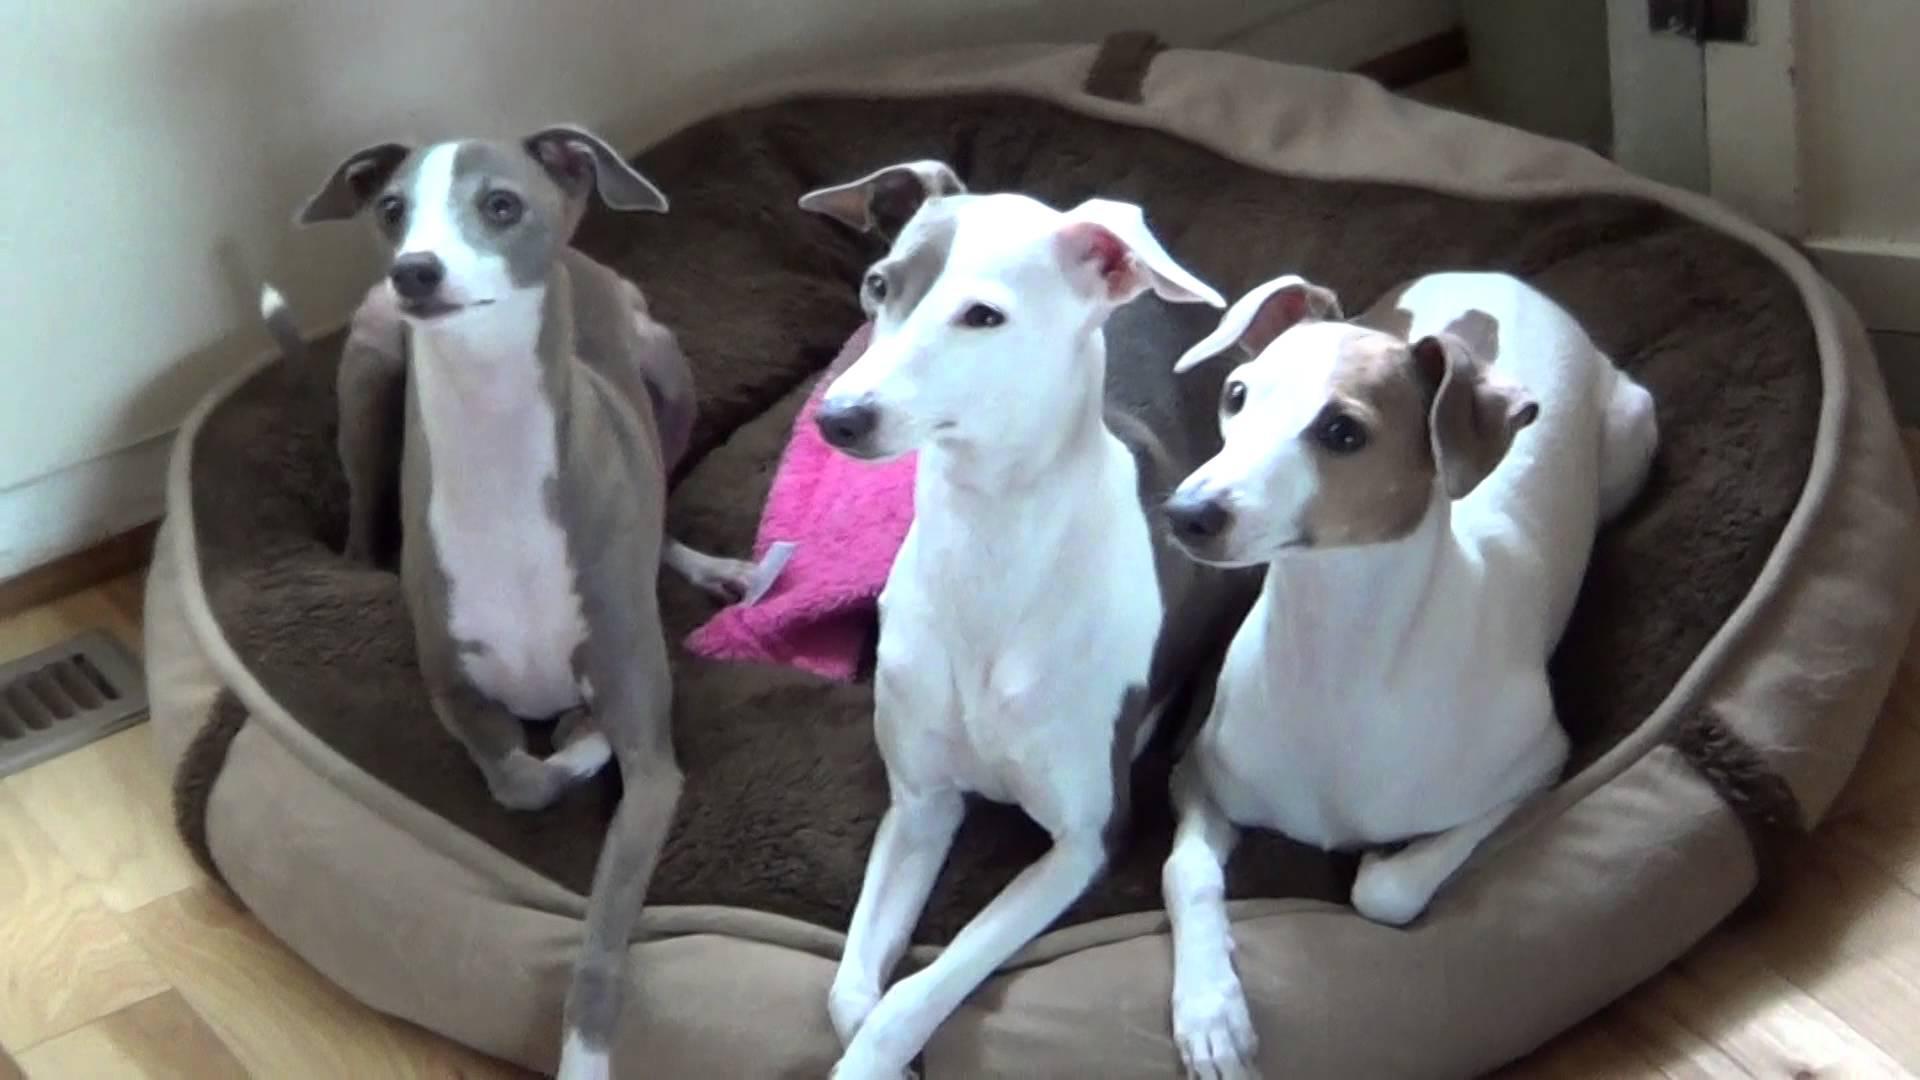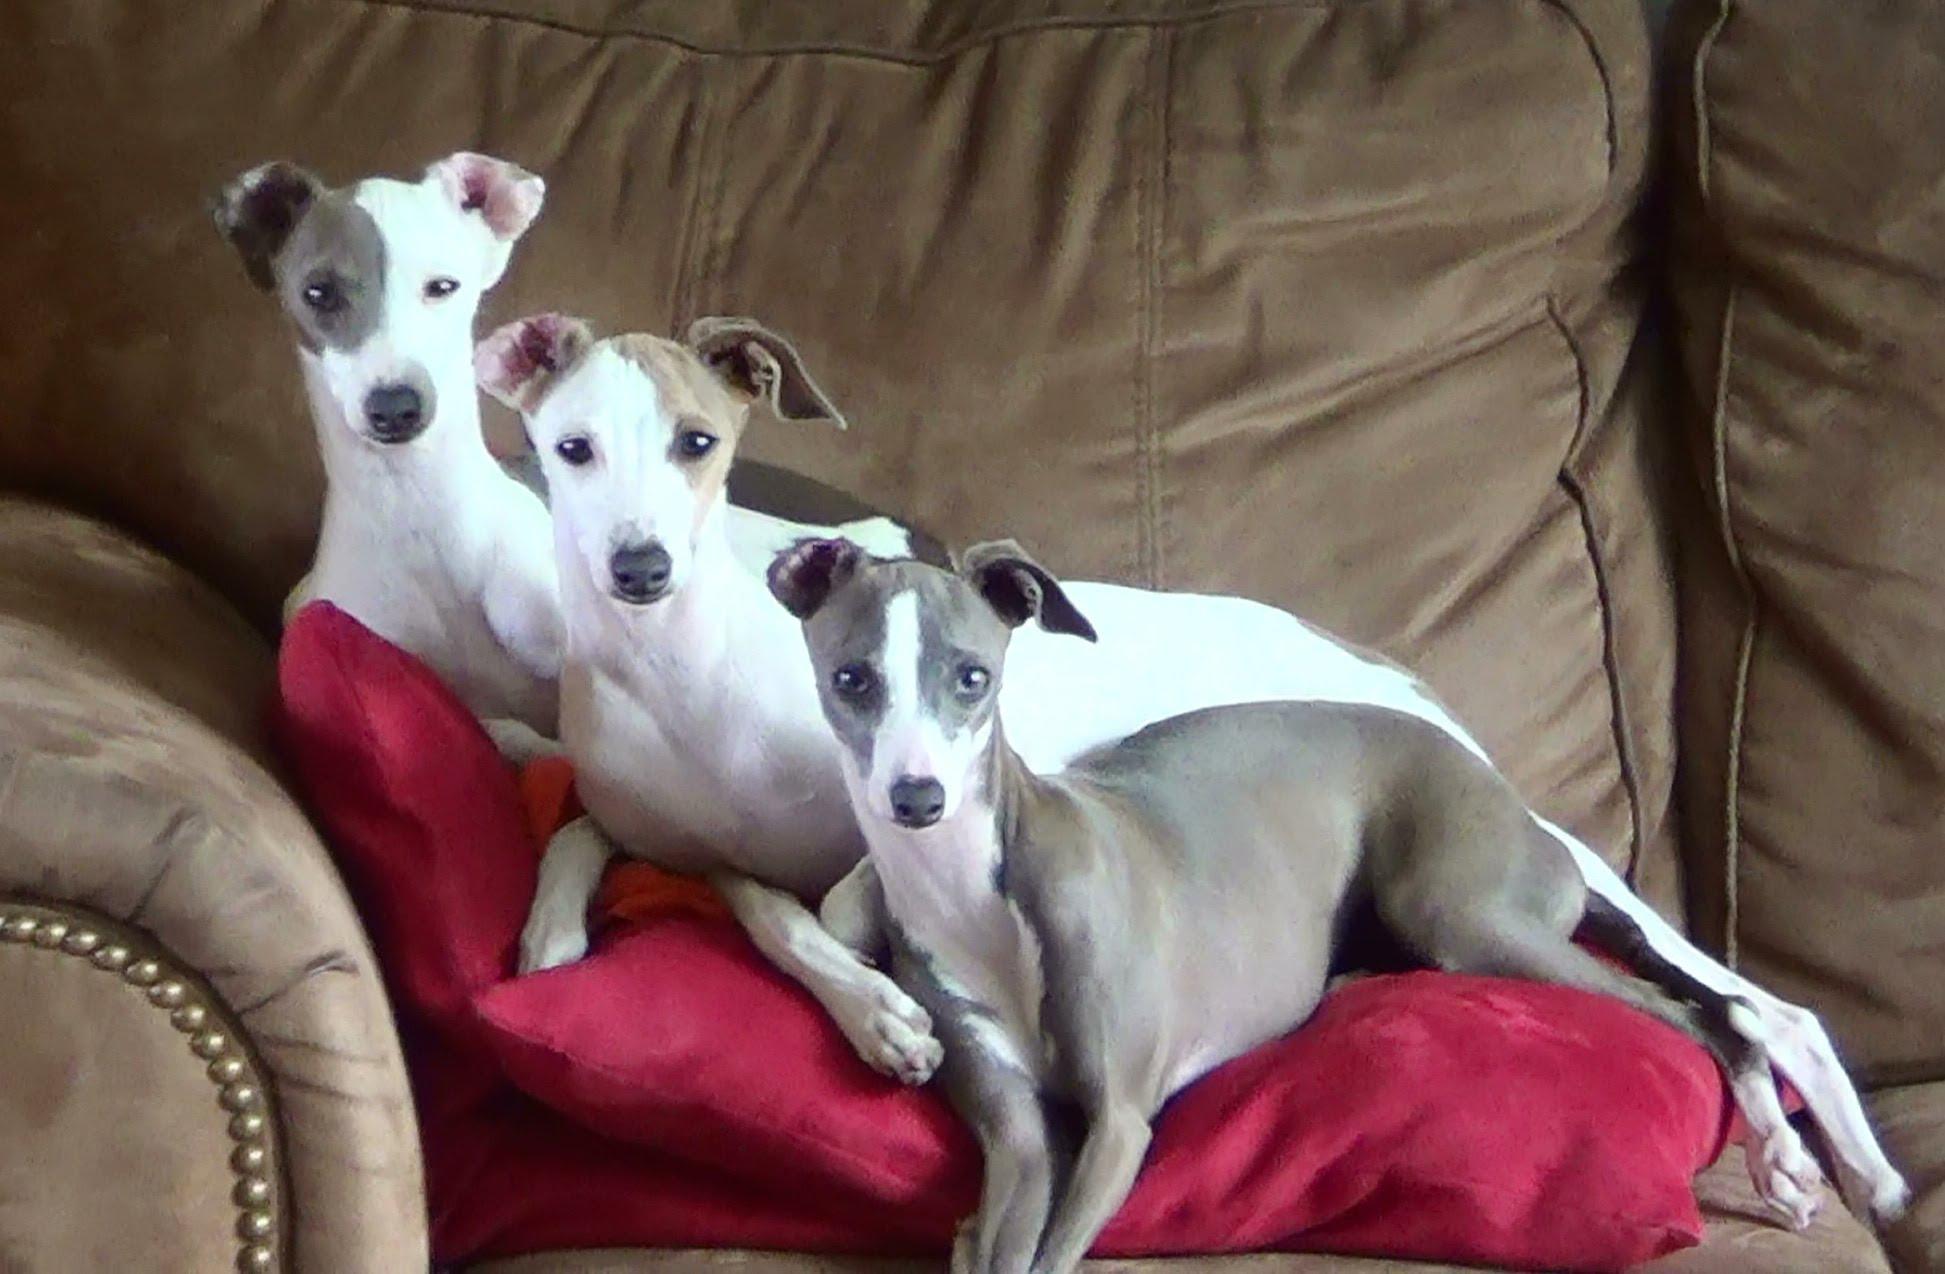The first image is the image on the left, the second image is the image on the right. Given the left and right images, does the statement "An image shows just one hound, reclining with paws extended forward." hold true? Answer yes or no. No. The first image is the image on the left, the second image is the image on the right. Assess this claim about the two images: "There are two dogs in total". Correct or not? Answer yes or no. No. 